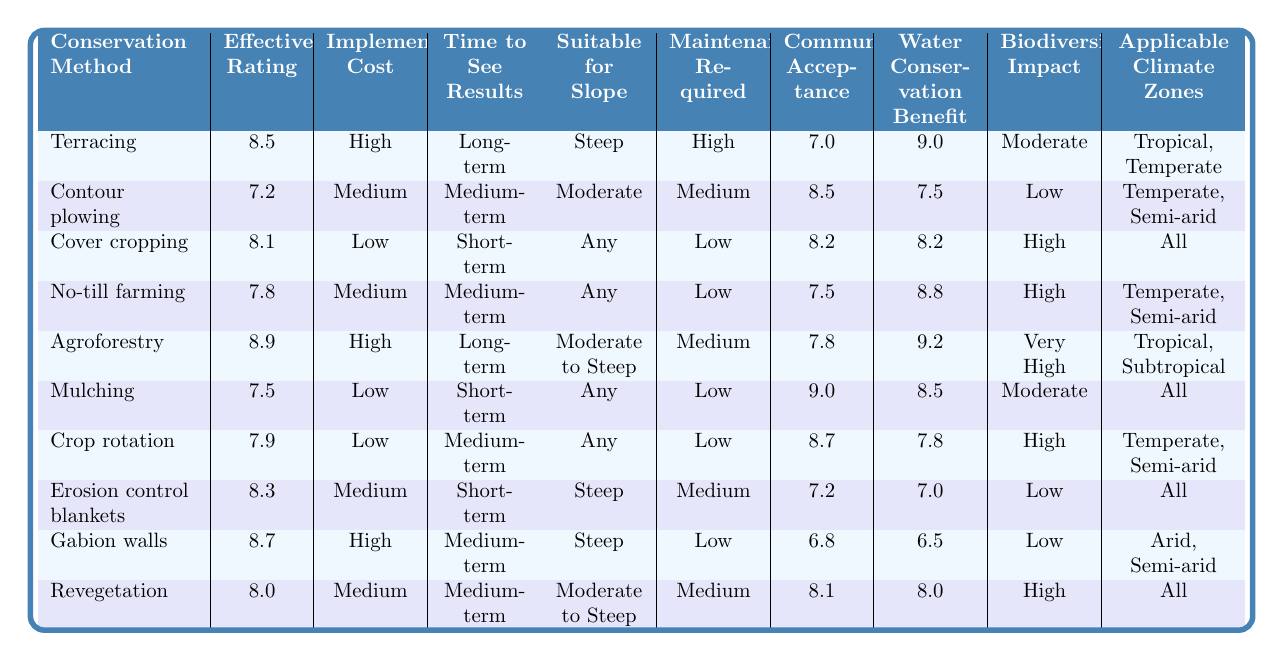What is the effectiveness rating of mulching? The table shows that the effectiveness rating of mulching is listed directly, which is 7.5.
Answer: 7.5 Which conservation method has the highest community acceptance? By reviewing the community acceptance ratings, agroforestry has a rating of 7.8, which is the highest among all methods.
Answer: Agroforestry What is the implementation cost of cover cropping? The table clearly states that the implementation cost for cover cropping is categorized as low.
Answer: Low How many conservation methods are suitable for steep slopes? The table indicates that terracing, erosion control blankets, and gabion walls are suitable for steep slopes. This gives a total of three methods.
Answer: 3 Is the effectiveness rating of no-till farming higher than that of contour plowing? The effectiveness rating for no-till farming is 7.8, while for contour plowing it is 7.2. Since 7.8 is greater than 7.2, the answer is yes.
Answer: Yes Which conservation method has both high effectiveness and high water conservation benefit? Among the listed methods, agroforestry has the highest effectiveness rating of 8.9 and a water conservation benefit rating of 9.2, fulfilling both criteria.
Answer: Agroforestry What is the average effectiveness rating of the methods that require low maintenance? The methods requiring low maintenance are cover cropping, mulching, crop rotation, and gabion walls, with effectiveness ratings of 8.1, 7.5, 7.9, and 8.7 respectively. The average is (8.1 + 7.5 + 7.9 + 8.7) / 4 = 8.05.
Answer: 8.05 Which two methods have a short-term time to see results? Looking at the table, cover cropping and mulching have a short-term time to see results, as indicated directly in their respective rows.
Answer: Cover cropping and mulching What is the biodiversity impact of gabion walls? The biodiversity impact for gabion walls is listed as low in the table.
Answer: Low Is there any conservation method that has a medium implementation cost and shows moderate biodiversity impact? By analyzing the table, both contour plowing and no-till farming have medium implementation costs, but only contour plowing has a low biodiversity impact. Thus, the answer is no.
Answer: No 